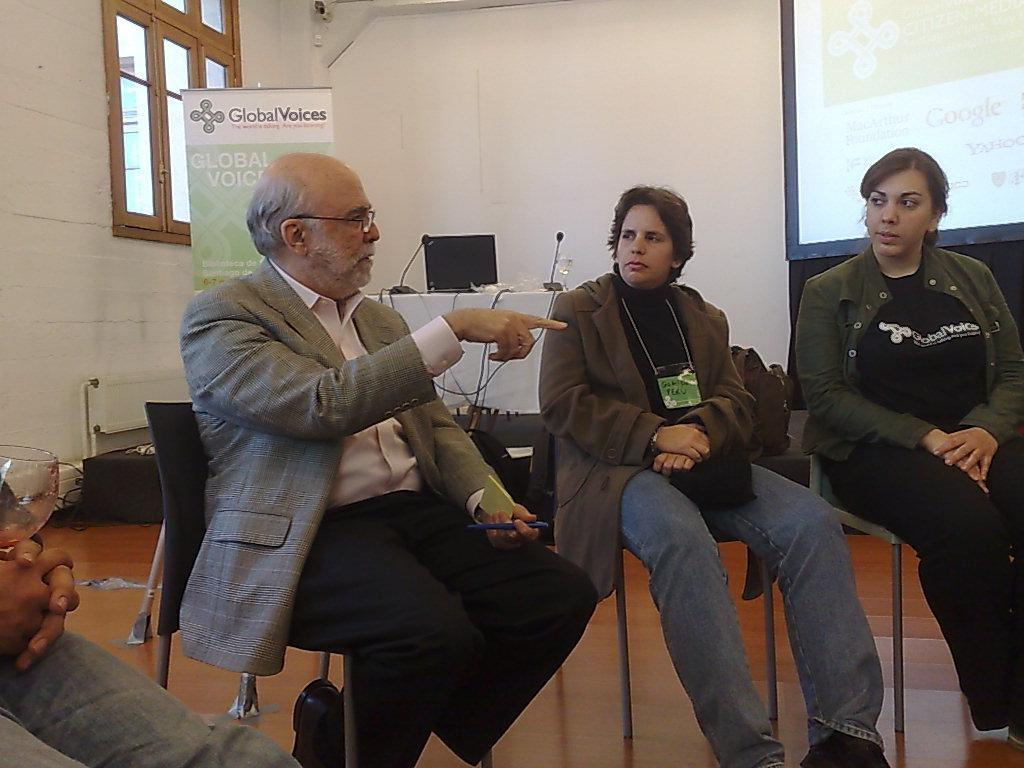What are the people in the image doing? The persons in the image are sitting on chairs. What can be seen in the background of the image? There is an advertisement, a table, a laptop, microphones, a glass tumbler, a screen, a window, and a wall in the background of the image. Can you describe the setting of the image? The image appears to be in a room with chairs, a table, and various electronic devices. What type of alley can be seen in the image? There is no alley present in the image; it is set in a room with chairs, a table, and various electronic devices. What is the primary interest of the people in the image? The image does not provide information about the interests of the people; they are simply sitting on chairs. 